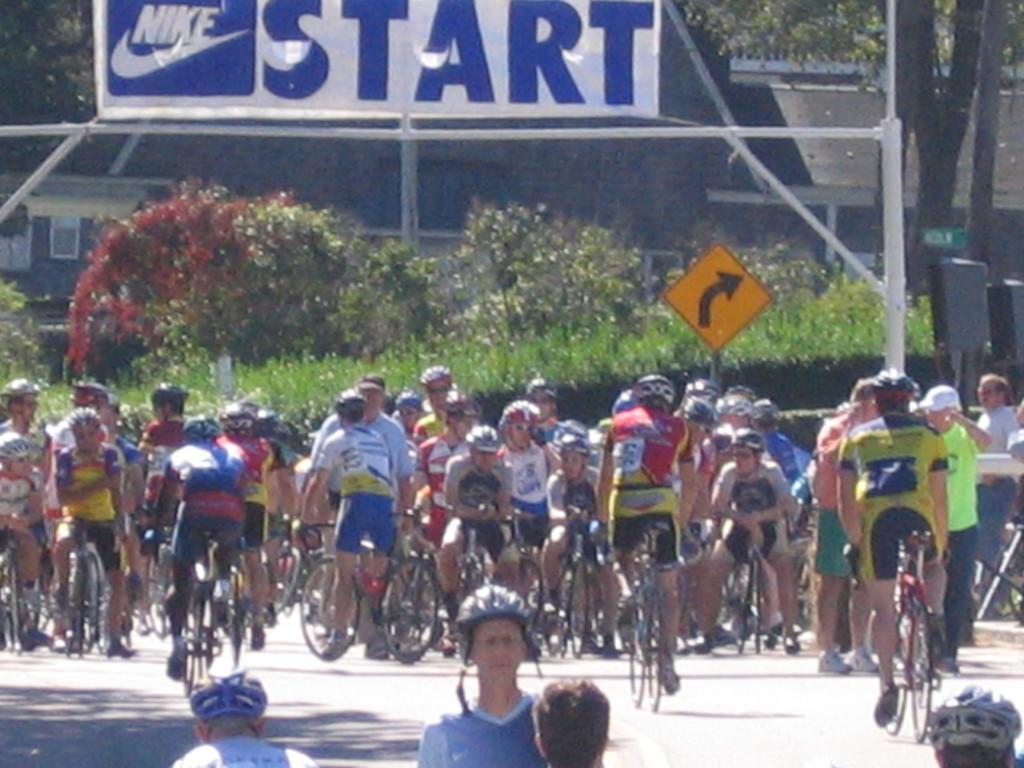Describe this image in one or two sentences. the image contains the many persons are riding the cycle and behind the person there are so many trees are there in the background is greenery 